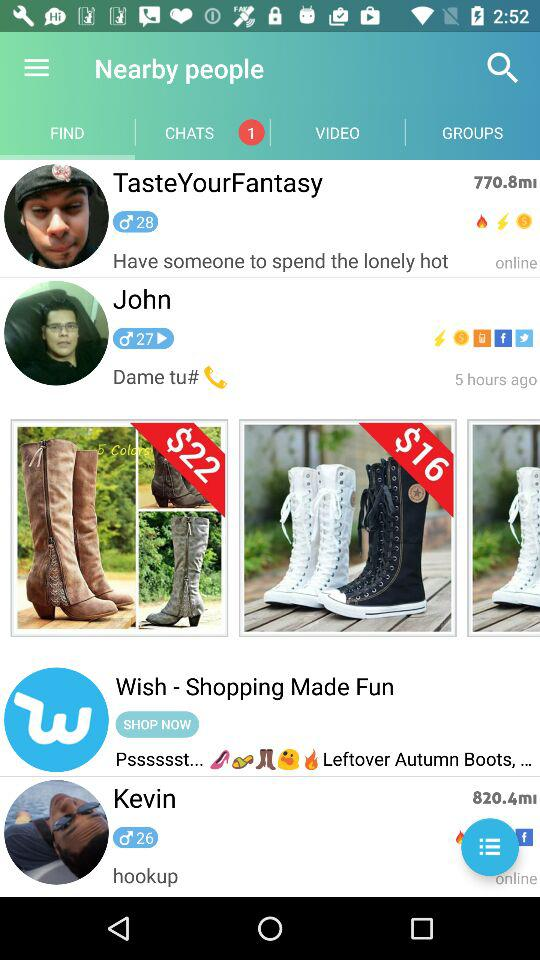How many chats were unread? The number of unread chats was 1. 